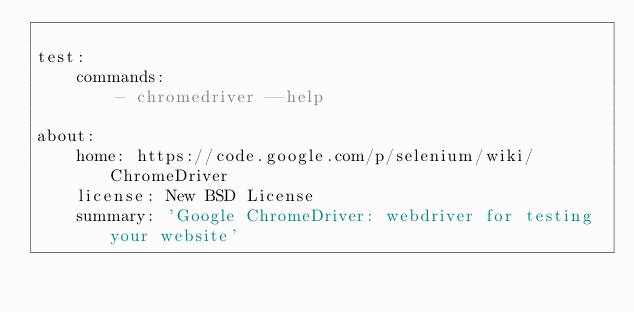<code> <loc_0><loc_0><loc_500><loc_500><_YAML_>
test:
    commands:
        - chromedriver --help

about:
    home: https://code.google.com/p/selenium/wiki/ChromeDriver
    license: New BSD License
    summary: 'Google ChromeDriver: webdriver for testing your website'
</code> 